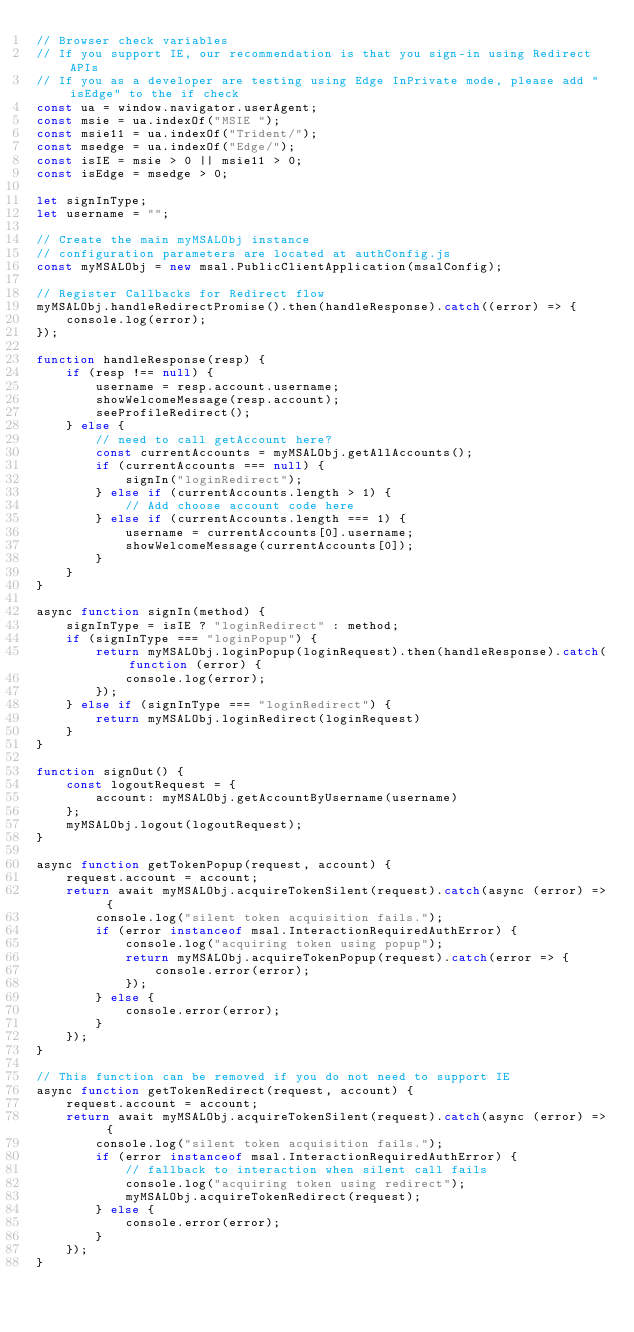<code> <loc_0><loc_0><loc_500><loc_500><_JavaScript_>// Browser check variables
// If you support IE, our recommendation is that you sign-in using Redirect APIs
// If you as a developer are testing using Edge InPrivate mode, please add "isEdge" to the if check
const ua = window.navigator.userAgent;
const msie = ua.indexOf("MSIE ");
const msie11 = ua.indexOf("Trident/");
const msedge = ua.indexOf("Edge/");
const isIE = msie > 0 || msie11 > 0;
const isEdge = msedge > 0;

let signInType;
let username = "";

// Create the main myMSALObj instance
// configuration parameters are located at authConfig.js
const myMSALObj = new msal.PublicClientApplication(msalConfig); 

// Register Callbacks for Redirect flow
myMSALObj.handleRedirectPromise().then(handleResponse).catch((error) => {
    console.log(error);
});

function handleResponse(resp) {
    if (resp !== null) {
        username = resp.account.username;
        showWelcomeMessage(resp.account);
        seeProfileRedirect();
    } else {
        // need to call getAccount here?
        const currentAccounts = myMSALObj.getAllAccounts();
        if (currentAccounts === null) {
            signIn("loginRedirect");
        } else if (currentAccounts.length > 1) {
            // Add choose account code here
        } else if (currentAccounts.length === 1) {
            username = currentAccounts[0].username;
            showWelcomeMessage(currentAccounts[0]);
        }
    }
}

async function signIn(method) {
    signInType = isIE ? "loginRedirect" : method;
    if (signInType === "loginPopup") {
        return myMSALObj.loginPopup(loginRequest).then(handleResponse).catch(function (error) {
            console.log(error);
        });
    } else if (signInType === "loginRedirect") {
        return myMSALObj.loginRedirect(loginRequest)
    }
}

function signOut() {
    const logoutRequest = {
        account: myMSALObj.getAccountByUsername(username)
    };
    myMSALObj.logout(logoutRequest);
}

async function getTokenPopup(request, account) {
    request.account = account;
    return await myMSALObj.acquireTokenSilent(request).catch(async (error) => {
        console.log("silent token acquisition fails.");
        if (error instanceof msal.InteractionRequiredAuthError) {
            console.log("acquiring token using popup");
            return myMSALObj.acquireTokenPopup(request).catch(error => {
                console.error(error);
            });
        } else {
            console.error(error);
        }
    });
}

// This function can be removed if you do not need to support IE
async function getTokenRedirect(request, account) {
    request.account = account;
    return await myMSALObj.acquireTokenSilent(request).catch(async (error) => {
        console.log("silent token acquisition fails.");
        if (error instanceof msal.InteractionRequiredAuthError) {
            // fallback to interaction when silent call fails
            console.log("acquiring token using redirect");
            myMSALObj.acquireTokenRedirect(request);
        } else {
            console.error(error);
        }
    });
}
</code> 